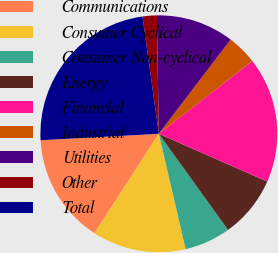Convert chart to OTSL. <chart><loc_0><loc_0><loc_500><loc_500><pie_chart><fcel>Communications<fcel>Consumer Cyclical<fcel>Consumer Non-cyclical<fcel>Energy<fcel>Financial<fcel>Industrial<fcel>Utilities<fcel>Other<fcel>Total<nl><fcel>14.97%<fcel>12.8%<fcel>6.29%<fcel>8.46%<fcel>17.14%<fcel>4.11%<fcel>10.63%<fcel>1.94%<fcel>23.66%<nl></chart> 